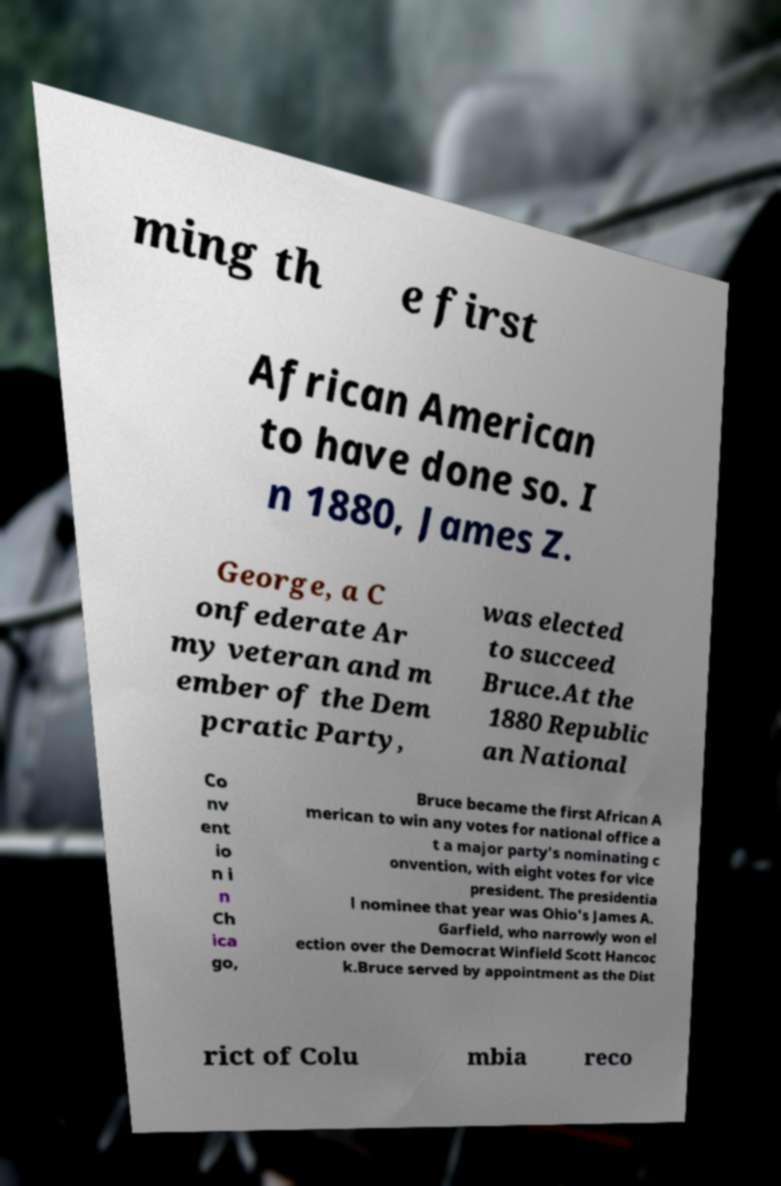Could you extract and type out the text from this image? ming th e first African American to have done so. I n 1880, James Z. George, a C onfederate Ar my veteran and m ember of the Dem pcratic Party, was elected to succeed Bruce.At the 1880 Republic an National Co nv ent io n i n Ch ica go, Bruce became the first African A merican to win any votes for national office a t a major party's nominating c onvention, with eight votes for vice president. The presidentia l nominee that year was Ohio's James A. Garfield, who narrowly won el ection over the Democrat Winfield Scott Hancoc k.Bruce served by appointment as the Dist rict of Colu mbia reco 